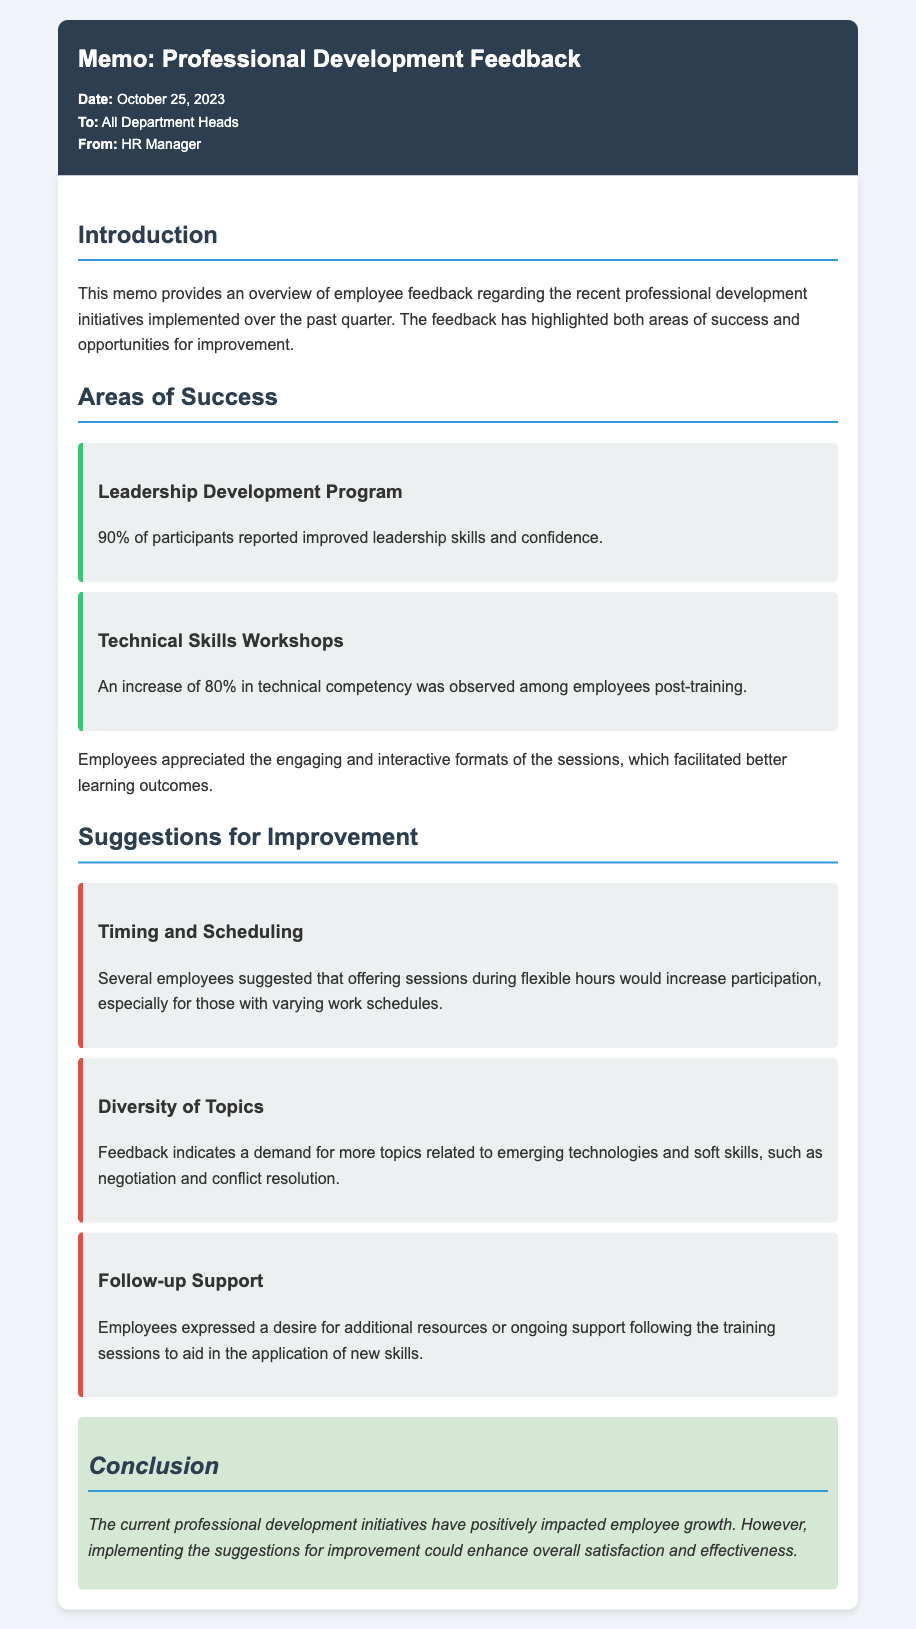What percentage of participants reported improved leadership skills? The feedback indicates that 90% of participants in the Leadership Development Program reported improved leadership skills.
Answer: 90% What was the increase in technical competency observed among employees post-training? The document states that there was an increase of 80% in technical competency among employees after the Technical Skills Workshops.
Answer: 80% What flexibility did employees suggest for training sessions? Employees suggested offering sessions during flexible hours for better participation.
Answer: Flexible hours Which type of skills did employees want more topics on? Feedback indicates a demand for topics related to emerging technologies and soft skills, such as negotiation and conflict resolution.
Answer: Emerging technologies and soft skills What is the date of the memo? The date of the memo, as provided in the document, is October 25, 2023.
Answer: October 25, 2023 Who is the memo intended for? The memo is directed to all department heads, as indicated in the 'To' section.
Answer: All Department Heads Which program had 90% positive feedback? The Leadership Development Program had 90% of participants reporting improved skills.
Answer: Leadership Development Program What kind of support do employees want after training? Employees expressed a desire for additional resources or ongoing support following the training sessions.
Answer: Additional resources or ongoing support 